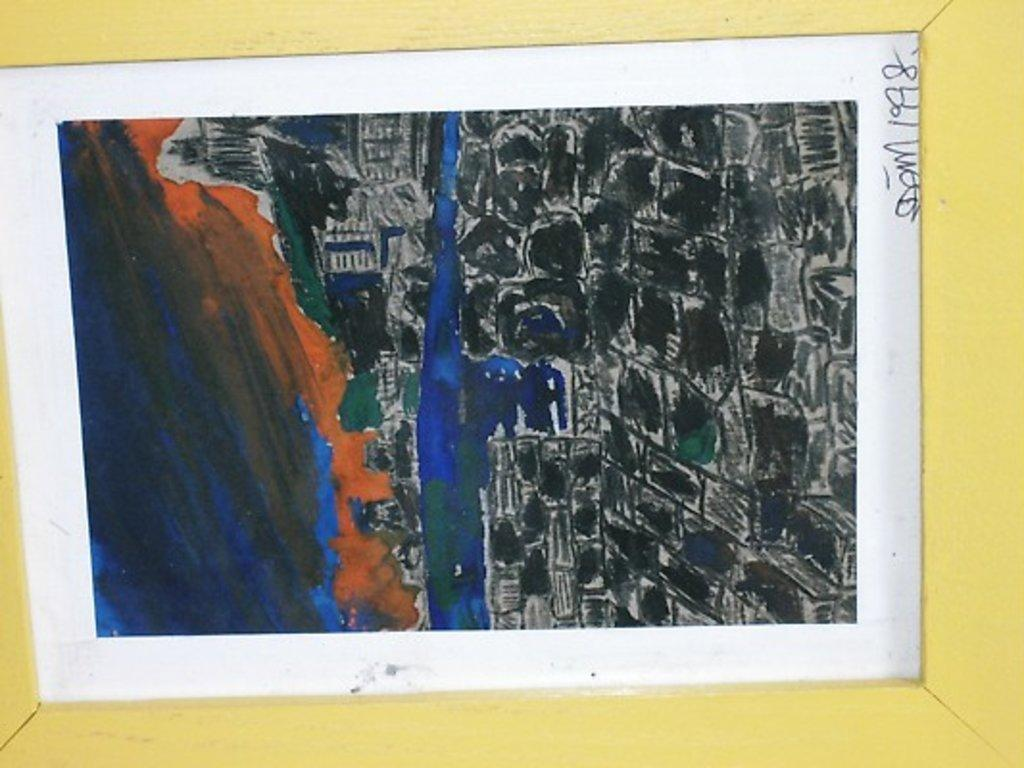What type of artwork is the image? The image is a painting. What subjects are depicted in the painting? There are paintings and mountains depicted in the image. What type of stamp is visible on the mountain in the image? There is no stamp present on the mountain in the image. What type of crime is being committed in the image? There is no crime depicted in the image; it features paintings and mountains. 